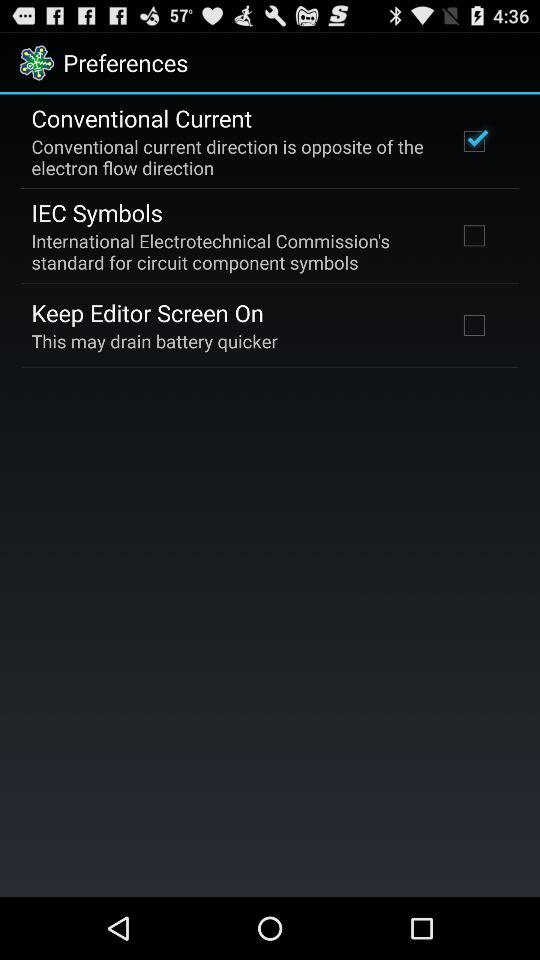What is the status of "Keep Editor Screen On"? The status of "Keep Editor Screen On" is "off". 